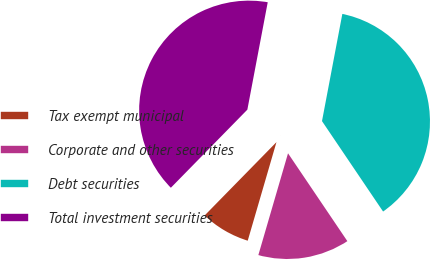<chart> <loc_0><loc_0><loc_500><loc_500><pie_chart><fcel>Tax exempt municipal<fcel>Corporate and other securities<fcel>Debt securities<fcel>Total investment securities<nl><fcel>7.82%<fcel>13.97%<fcel>37.56%<fcel>40.65%<nl></chart> 